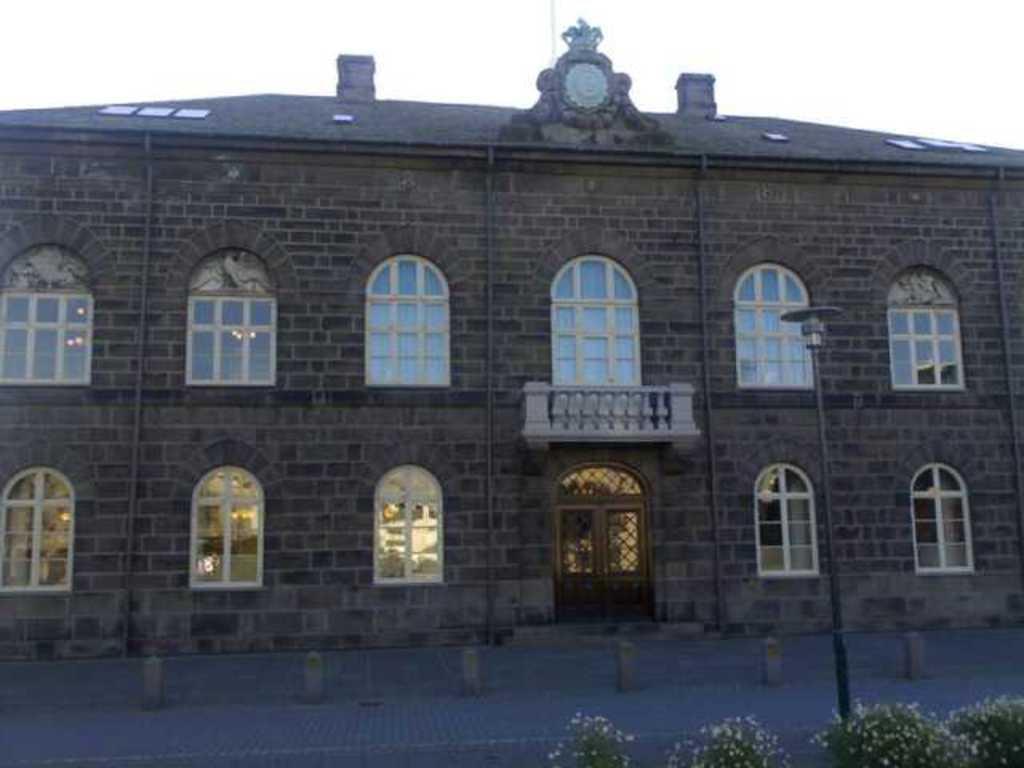Describe this image in one or two sentences. In this image we can see a building, doors, windows, plants, flowers, pole, and road. In the background there is sky. 